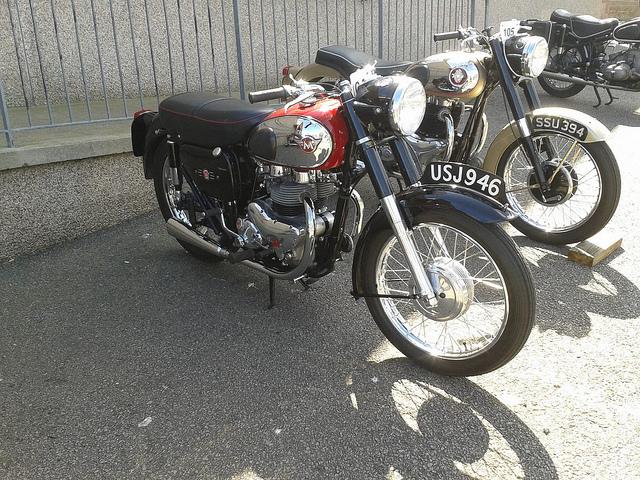How many bikes are the same color?
Keep it brief. 2. How many bikes?
Concise answer only. 3. Are these bikes expensive?
Give a very brief answer. Yes. What is next to the motorcycle?
Answer briefly. Another motorcycle. What color rims does the nearest bike have?
Short answer required. Silver. What is the combination of letters and numbers on the tags of the motorcycles?
Give a very brief answer. Usj 946ssu394. 